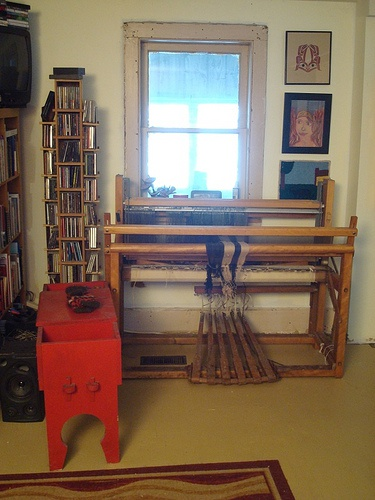Describe the objects in this image and their specific colors. I can see book in black, maroon, and gray tones, tv in black and gray tones, book in black, maroon, and gray tones, book in black, maroon, and brown tones, and book in black and gray tones in this image. 